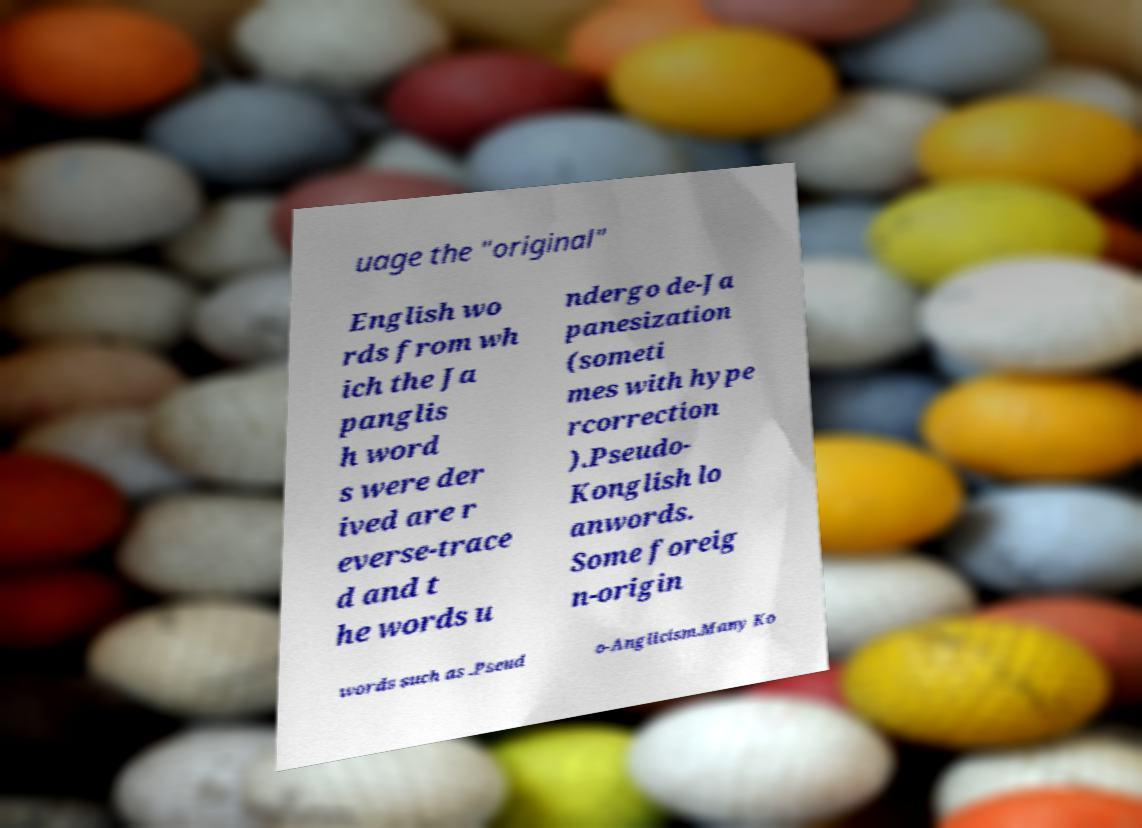Please read and relay the text visible in this image. What does it say? uage the "original" English wo rds from wh ich the Ja panglis h word s were der ived are r everse-trace d and t he words u ndergo de-Ja panesization (someti mes with hype rcorrection ).Pseudo- Konglish lo anwords. Some foreig n-origin words such as .Pseud o-Anglicism.Many Ko 